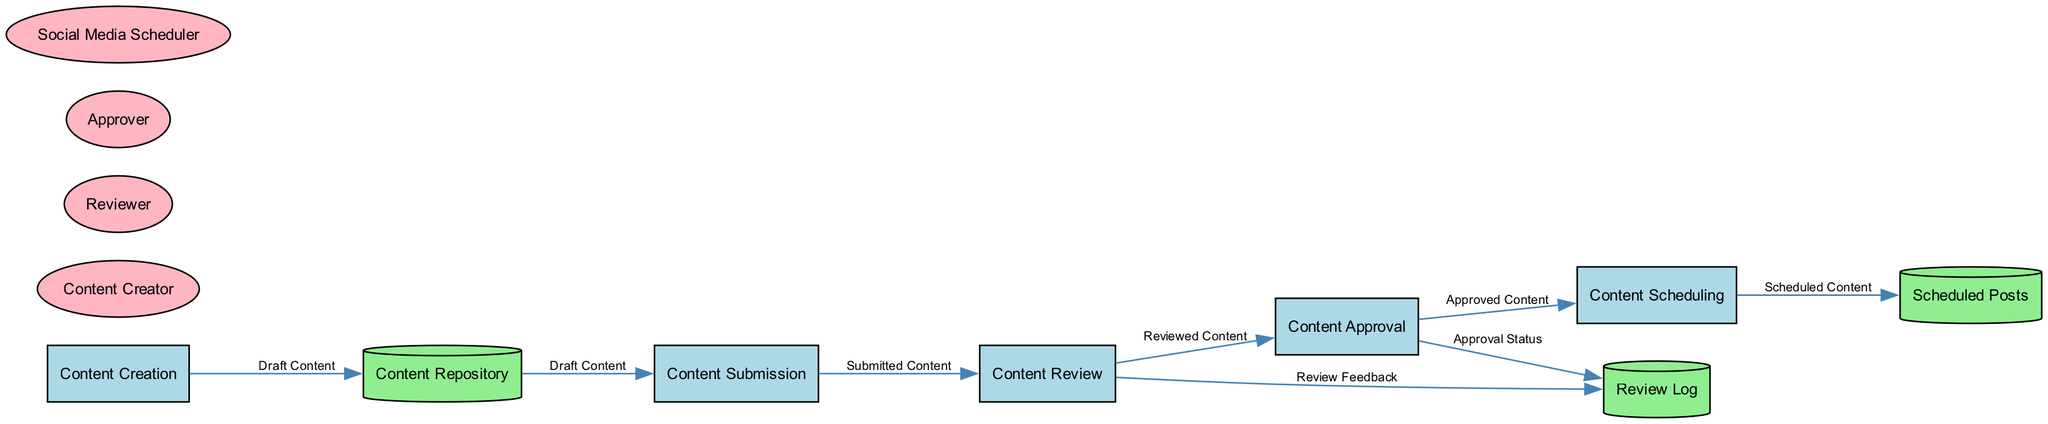What is the name of the first process? The first process in the diagram is identified as "Content Creation." By observing the nodes labeled with process identifiers, we can see that the one associated with ID "1" is named "Content Creation."
Answer: Content Creation How many data stores are present in the diagram? The diagram includes three data stores: "Content Repository," "Review Log," and "Scheduled Posts." By counting the nodes labeled as data stores, we find that there are three distinct stores in total.
Answer: 3 Which external entity is responsible for content scheduling? The external entity tasked with scheduling content is labeled "Social Media Scheduler." This entity appears distinctly in the diagram as responsible for the scheduling function, which is identified by its respective label.
Answer: Social Media Scheduler What data flows from Content Approval to Content Scheduling? The data that flows from "Content Approval" to "Content Scheduling" is labeled "Approved Content." This connection is indicated by the edge connecting these two nodes, which specifies the type of data being transferred.
Answer: Approved Content How many processes are reviewed before content approval? There are two stages before content approval: "Content Submission" and "Content Review." By analyzing the data flow and the sequence of processes, we establish that these two distinct processes occur prior to the approval stage.
Answer: 2 What information does the Review Log store from Content Review? The Review Log stores "Review Feedback" obtained from the "Content Review" process. The data flow indicates that feedback generated during the review stage is directed towards the Review Log for future reference.
Answer: Review Feedback Which process follows Content Submission? The process that follows "Content Submission" is "Content Review." By tracing the arrows in the diagram, we see that the data flows directly from "Content Submission" to "Content Review," indicating the sequence of processes.
Answer: Content Review How many total processes are there in the diagram? The diagram contains a total of five processes: "Content Creation," "Content Submission," "Content Review," "Content Approval," and "Content Scheduling." By counting all nodes labeled as processes, we arrive at this total.
Answer: 5 What does the data flow from Content Review to the Review Log represent? The data flow from "Content Review" to "Review Log" represents "Review Feedback." Observing the flow, it indicates that feedback generated during the review is recorded in the log for tracking and reference purposes.
Answer: Review Feedback 